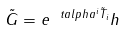Convert formula to latex. <formula><loc_0><loc_0><loc_500><loc_500>\tilde { G } = e ^ { \ t a l p h a ^ { i } \tilde { T } _ { i } } h \</formula> 